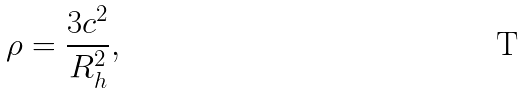<formula> <loc_0><loc_0><loc_500><loc_500>\rho = \frac { 3 c ^ { 2 } } { R _ { h } ^ { 2 } } ,</formula> 